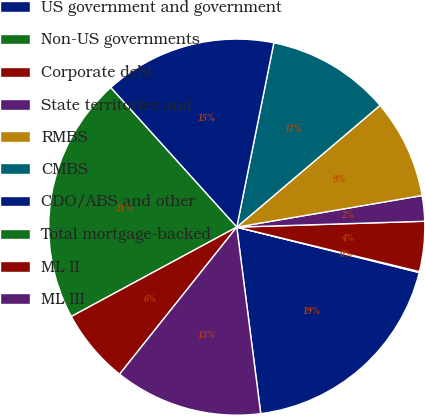<chart> <loc_0><loc_0><loc_500><loc_500><pie_chart><fcel>US government and government<fcel>Non-US governments<fcel>Corporate debt<fcel>State territories and<fcel>RMBS<fcel>CMBS<fcel>CDO/ABS and other<fcel>Total mortgage-backed<fcel>ML II<fcel>ML III<nl><fcel>19.08%<fcel>0.08%<fcel>4.3%<fcel>2.19%<fcel>8.52%<fcel>10.63%<fcel>14.85%<fcel>21.19%<fcel>6.41%<fcel>12.74%<nl></chart> 